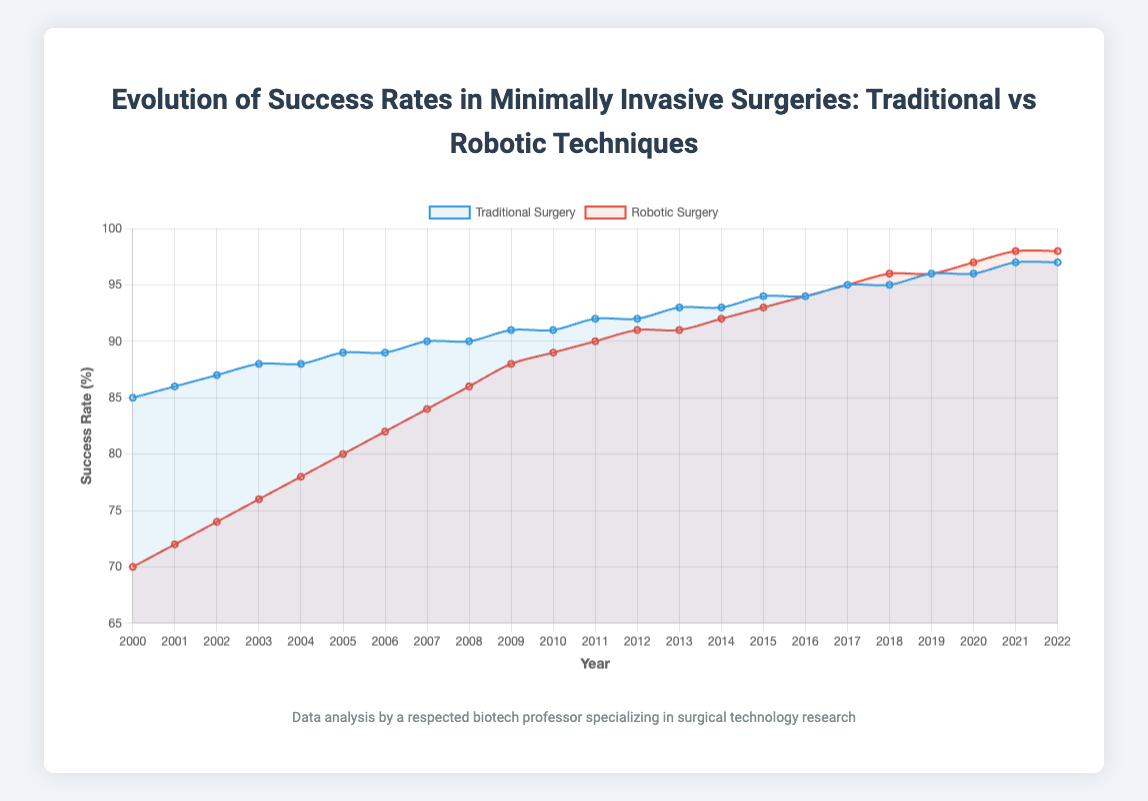Which year did robotic surgery success rates surpass 90%? By examining the plot line for robotic surgery, we see that the success rates first cross the 90% threshold in 2012.
Answer: 2012 What is the difference in success rates between traditional surgery and robotic surgery for the year 2003? For 2003, the success rate for traditional surgery is 88%, and for robotic surgery, it is 76%. The difference is 88% - 76% = 12%.
Answer: 12% In which years are the success rates of robotic surgery and traditional surgery equal? By examining the plot, the success rates for both types of surgeries are equal in 2016 and 2017 when both lines converge at the same success rates for these years.
Answer: 2016 and 2017 How many years did it take for robotic surgery success rates to catch up with traditional surgery from 2000? In 2000, the success rate for traditional surgery is 85%, and for robotic surgery, it is 70%. They first equalize in 2016, so it took 16 years (2016 - 2000 = 16).
Answer: 16 years What is the overall trend in success rates for traditional surgery from 2000 to 2022? The trend line for traditional surgery shows a gradual increase in success rates from 85% in 2000 to 97% in 2022.
Answer: Gradual increase Compare the increments in success rates for traditional surgery and robotic surgery between the years 2010 and 2015. From the data: Traditional surgery in 2010 was 91% and in 2015 was 94%, an increase of 3%. Robotic surgery in 2010 was 89% and in 2015 was 93%, an increase of 4%.
Answer: Traditional: 3%, Robotic: 4% Between 2005 and 2010, what was the average success rate for robotic surgery? The success rates for robotic surgery from 2005 to 2010 are 80%, 82%, 84%, 86%, 88%, and 89%. The average is (80% + 82% + 84% + 86% + 88% + 89%) / 6 = 84.83%.
Answer: 84.83% What visual attribute indicates which surgical technique has higher success rates post-2016? Post-2016, the red-colored line representing robotic surgery is consistently above the blue line representing traditional surgery, indicating higher success rates.
Answer: Red line for robotic surgery is higher What is the slope of the success rate increase for robotic surgery between 2000 and 2020, assuming a linear relationship? Robotic surgery starts at 70% in 2000 and reaches 97% in 2020. The slope is calculated by (97% - 70%) / (2020 - 2000) = 27% / 20 years = 1.35% per year.
Answer: 1.35% per year During which decade did robotic surgery see the most significant increase in success rates? By examining the plot, the most significant increase in robotic surgery success rates appears between 2000 and 2010, where it increases from 70% to 89%, a rise of 19%.
Answer: 2000-2010 